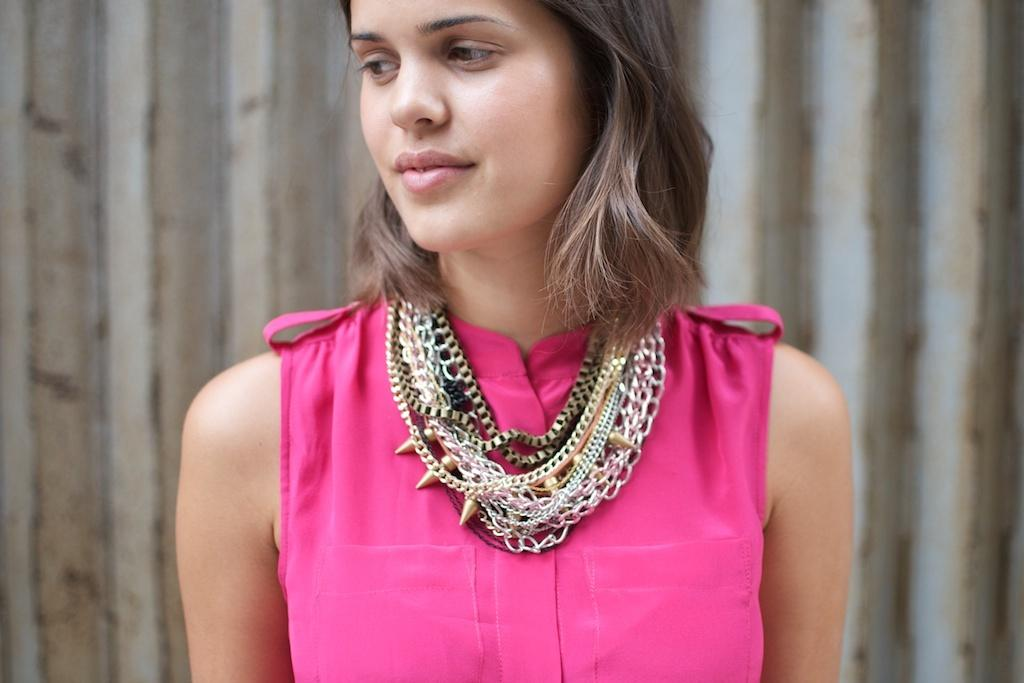What is the main subject of the image? The main subject of the image is a lady. What is the lady wearing in the image? The lady is wearing a pink dress. Are there any accessories visible on the lady in the image? Yes, the lady is wearing necklaces. What type of story is the lady telling in the image? There is no indication in the image that the lady is telling a story. What type of metal is used to make the necklaces the lady is wearing? There is no information about the type of metal used to make the necklaces in the image. 